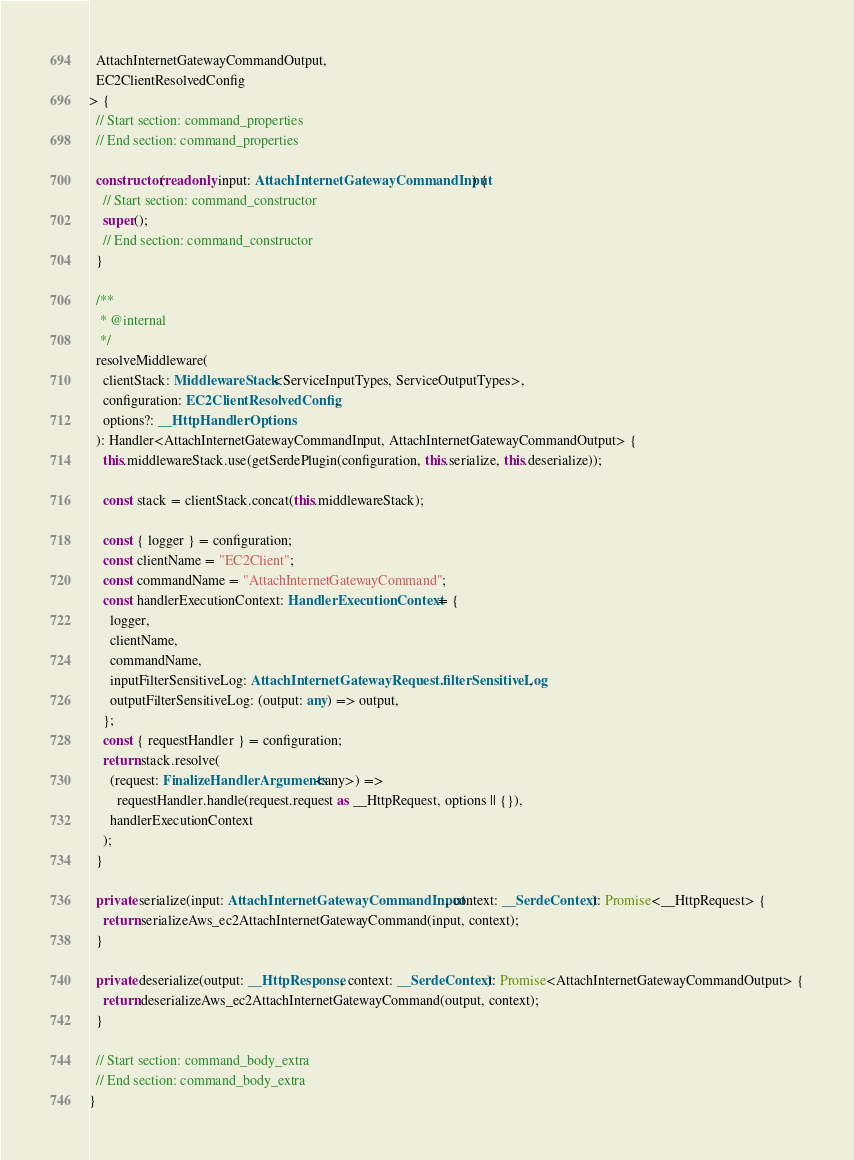Convert code to text. <code><loc_0><loc_0><loc_500><loc_500><_TypeScript_>  AttachInternetGatewayCommandOutput,
  EC2ClientResolvedConfig
> {
  // Start section: command_properties
  // End section: command_properties

  constructor(readonly input: AttachInternetGatewayCommandInput) {
    // Start section: command_constructor
    super();
    // End section: command_constructor
  }

  /**
   * @internal
   */
  resolveMiddleware(
    clientStack: MiddlewareStack<ServiceInputTypes, ServiceOutputTypes>,
    configuration: EC2ClientResolvedConfig,
    options?: __HttpHandlerOptions
  ): Handler<AttachInternetGatewayCommandInput, AttachInternetGatewayCommandOutput> {
    this.middlewareStack.use(getSerdePlugin(configuration, this.serialize, this.deserialize));

    const stack = clientStack.concat(this.middlewareStack);

    const { logger } = configuration;
    const clientName = "EC2Client";
    const commandName = "AttachInternetGatewayCommand";
    const handlerExecutionContext: HandlerExecutionContext = {
      logger,
      clientName,
      commandName,
      inputFilterSensitiveLog: AttachInternetGatewayRequest.filterSensitiveLog,
      outputFilterSensitiveLog: (output: any) => output,
    };
    const { requestHandler } = configuration;
    return stack.resolve(
      (request: FinalizeHandlerArguments<any>) =>
        requestHandler.handle(request.request as __HttpRequest, options || {}),
      handlerExecutionContext
    );
  }

  private serialize(input: AttachInternetGatewayCommandInput, context: __SerdeContext): Promise<__HttpRequest> {
    return serializeAws_ec2AttachInternetGatewayCommand(input, context);
  }

  private deserialize(output: __HttpResponse, context: __SerdeContext): Promise<AttachInternetGatewayCommandOutput> {
    return deserializeAws_ec2AttachInternetGatewayCommand(output, context);
  }

  // Start section: command_body_extra
  // End section: command_body_extra
}
</code> 